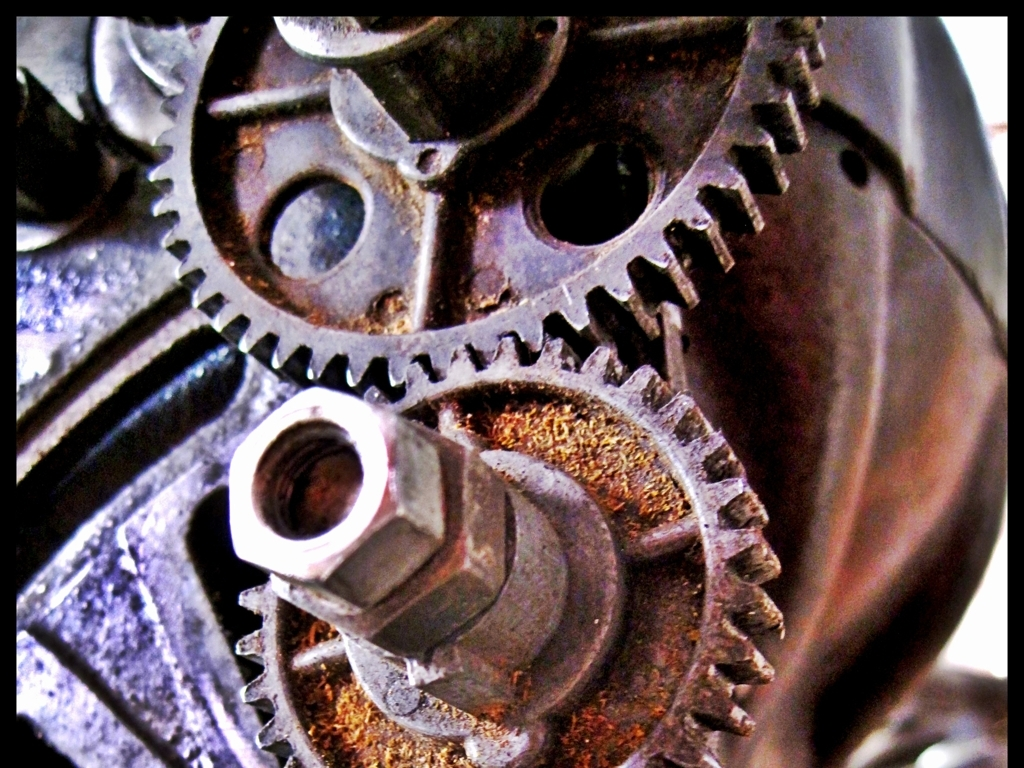What do the colors and textures in the image tell us about the environment? The predominance of brown hues, especially the rust on the gears, implies a damp and possibly neglected environment that has contributed to the corrosion. The different textures ranging from smooth metallic areas to gritty corroded surfaces suggest a history of use and exposure to harsh conditions. 